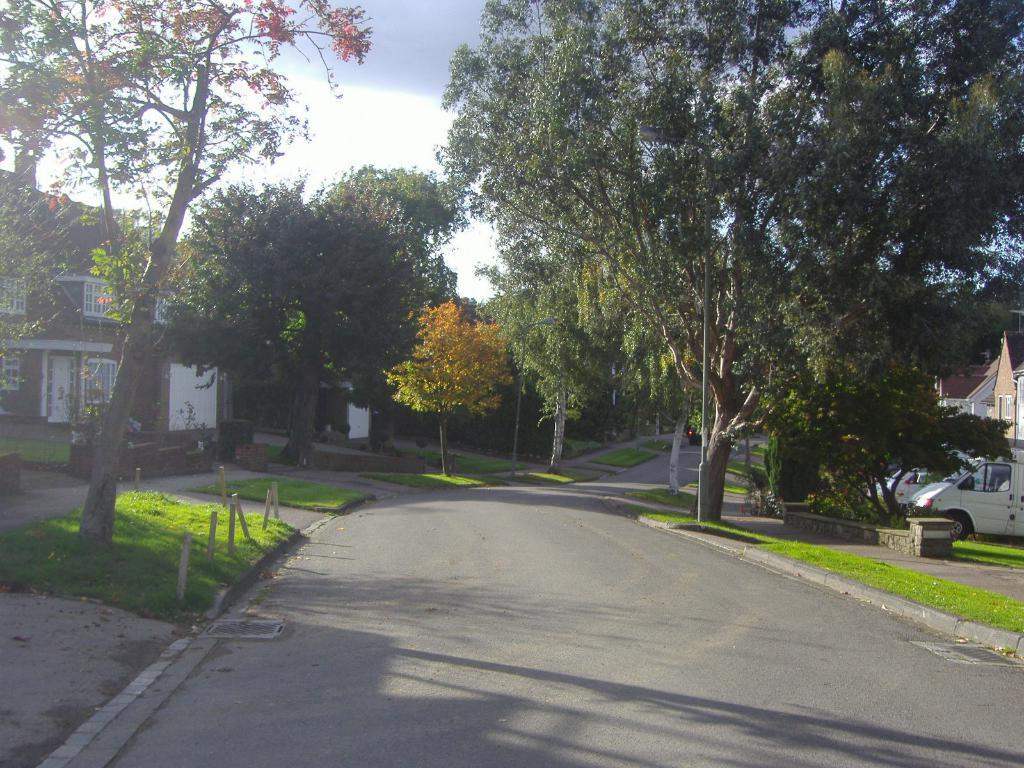What is the main feature of the image? There is a road in the image. What can be seen on the right side of the road? On the right side of the image, there is a car. What is located on the left side of the road? On the left side of the image, there are homes. What type of vegetation is present in the image? There are trees in the image. What is visible at the top of the image? The sky is visible at the top of the image. What type of sink can be seen in the image? There is no sink present in the image. What is the visibility of the mist in the image? There is no mention of mist in the image; it only shows a road, a car, homes, trees, and the sky. 